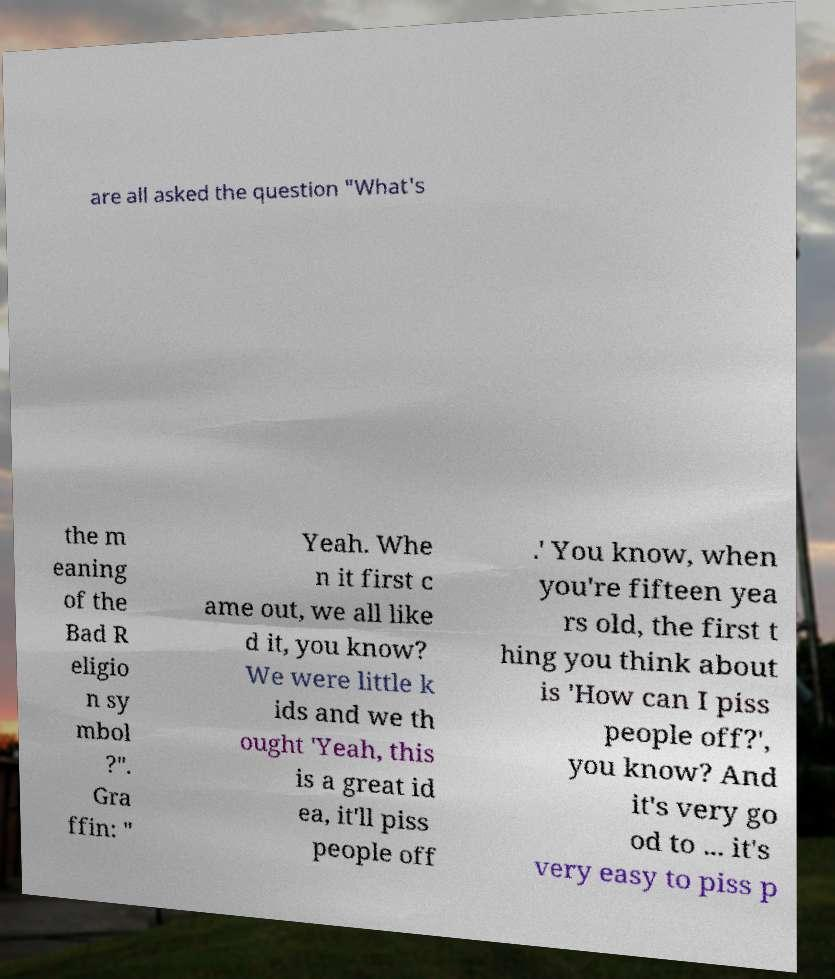There's text embedded in this image that I need extracted. Can you transcribe it verbatim? are all asked the question "What's the m eaning of the Bad R eligio n sy mbol ?". Gra ffin: " Yeah. Whe n it first c ame out, we all like d it, you know? We were little k ids and we th ought 'Yeah, this is a great id ea, it'll piss people off .' You know, when you're fifteen yea rs old, the first t hing you think about is 'How can I piss people off?', you know? And it's very go od to ... it's very easy to piss p 